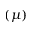Convert formula to latex. <formula><loc_0><loc_0><loc_500><loc_500>( \mu )</formula> 